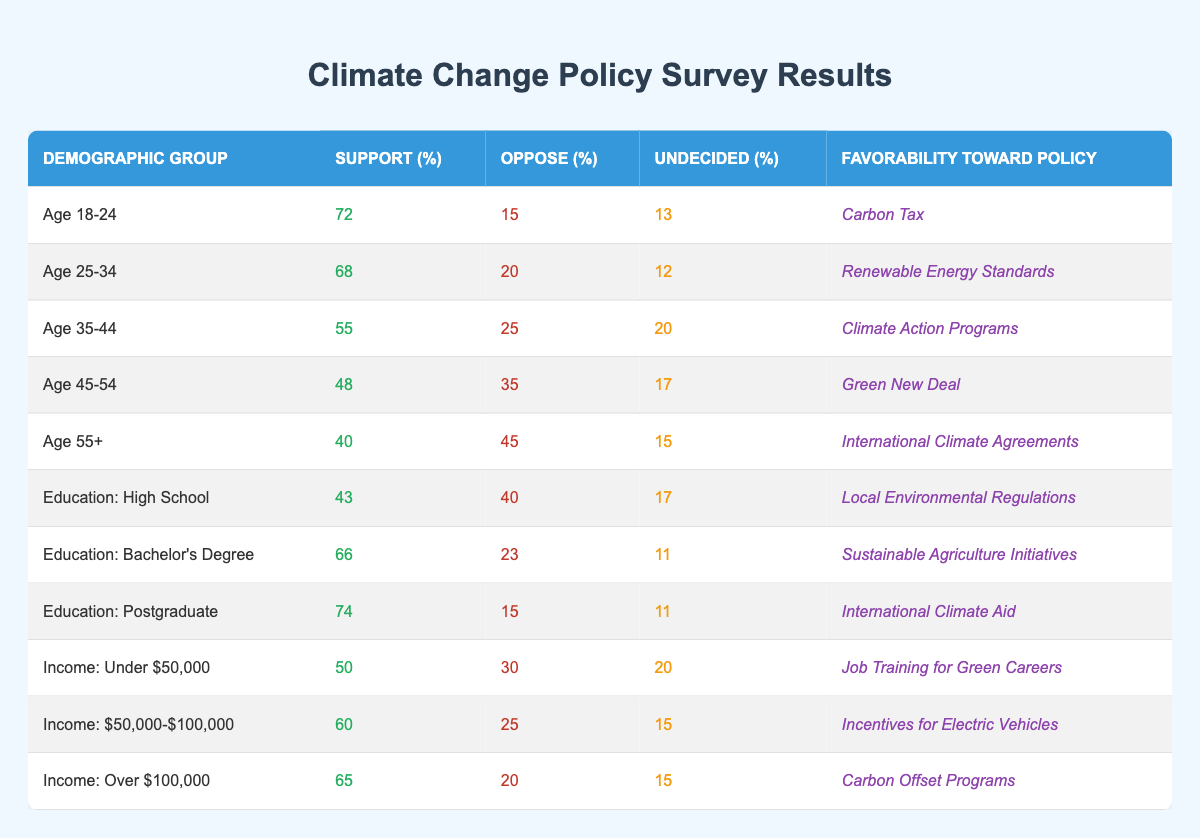What percentage of the Age 18-24 demographic supports the Carbon Tax? The table shows that the support percentage for the Carbon Tax within the Age 18-24 demographic is 72%.
Answer: 72% Which demographic shows the highest support for renewable energy policies? According to the table, the demographic group Age 25-34 has a support percentage of 68% for Renewable Energy Standards, which is the highest among listed demographics.
Answer: Age 25-34 What is the average support percentage for demographics with a postgraduate education? We look at the support percentages for education levels: Postgraduate (74%), Bachelor's Degree (66%), and High School (43%). The average is calculated as (74 + 66 + 43) / 3 = 61.
Answer: 61 Is the support percentage for the Green New Deal higher than that for the Climate Action Programs? The table shows that 48% of the Age 45-54 demographic supports the Green New Deal and 55% supports Climate Action Programs (Age 35-44 demographic). Since 55% is greater than 48%, the statement is false.
Answer: No What is the total percentage of support for climate policies among the Age 55+ demographic? The table indicates that the support percentage for the Age 55+ group is 40%. This is the total percentage for that demographic.
Answer: 40% How does the support for job training for green careers compare between income levels under $50,000 and over $100,000? The support percentage for income under $50,000 is 50%, while for income over $100,000 it is 65%. Comparing these, 65% is 15% higher than 50%, indicating greater support from the higher income demographic.
Answer: Higher income shows more support What percentage of the respondents with a Bachelor’s Degree are undecided about sustainable agriculture initiatives? The data shows that the undecided percentage for Bachelor's Degree holders regarding Sustainable Agriculture Initiatives is 11%.
Answer: 11% Which demographic is the least supportive of climate policies based on the provided data? Analysis of the support percentages indicates that the Age 55+ demographic, with a support percentage of 40%, is the least supportive amongst the listed demographics.
Answer: Age 55+ 